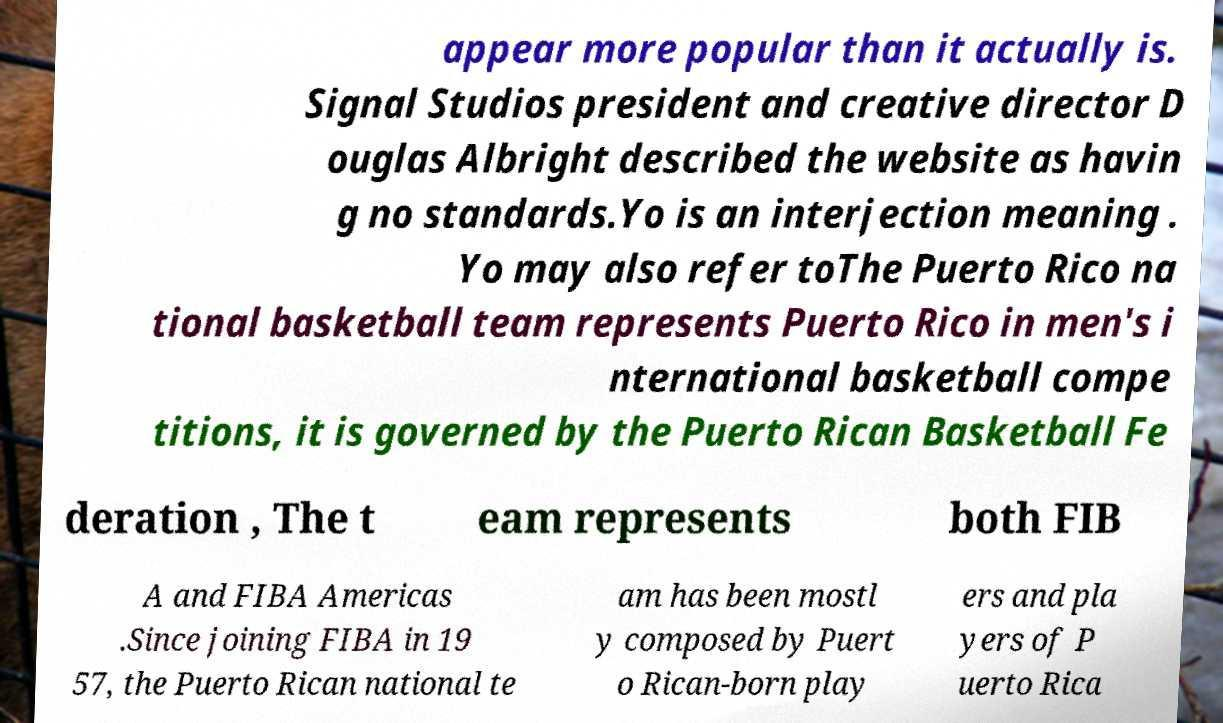Please identify and transcribe the text found in this image. appear more popular than it actually is. Signal Studios president and creative director D ouglas Albright described the website as havin g no standards.Yo is an interjection meaning . Yo may also refer toThe Puerto Rico na tional basketball team represents Puerto Rico in men's i nternational basketball compe titions, it is governed by the Puerto Rican Basketball Fe deration , The t eam represents both FIB A and FIBA Americas .Since joining FIBA in 19 57, the Puerto Rican national te am has been mostl y composed by Puert o Rican-born play ers and pla yers of P uerto Rica 